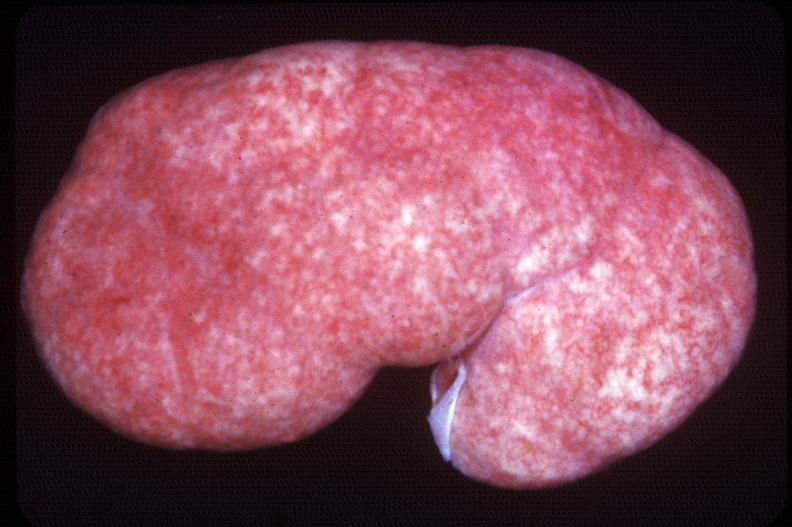what does this image show?
Answer the question using a single word or phrase. Kidney 